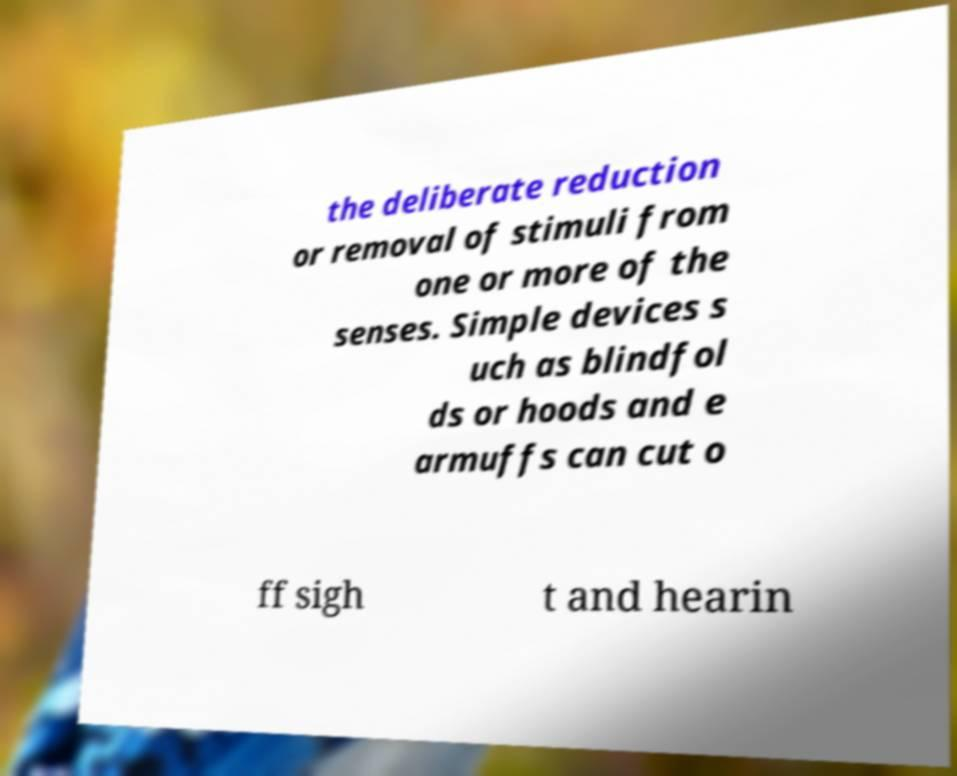Please read and relay the text visible in this image. What does it say? the deliberate reduction or removal of stimuli from one or more of the senses. Simple devices s uch as blindfol ds or hoods and e armuffs can cut o ff sigh t and hearin 